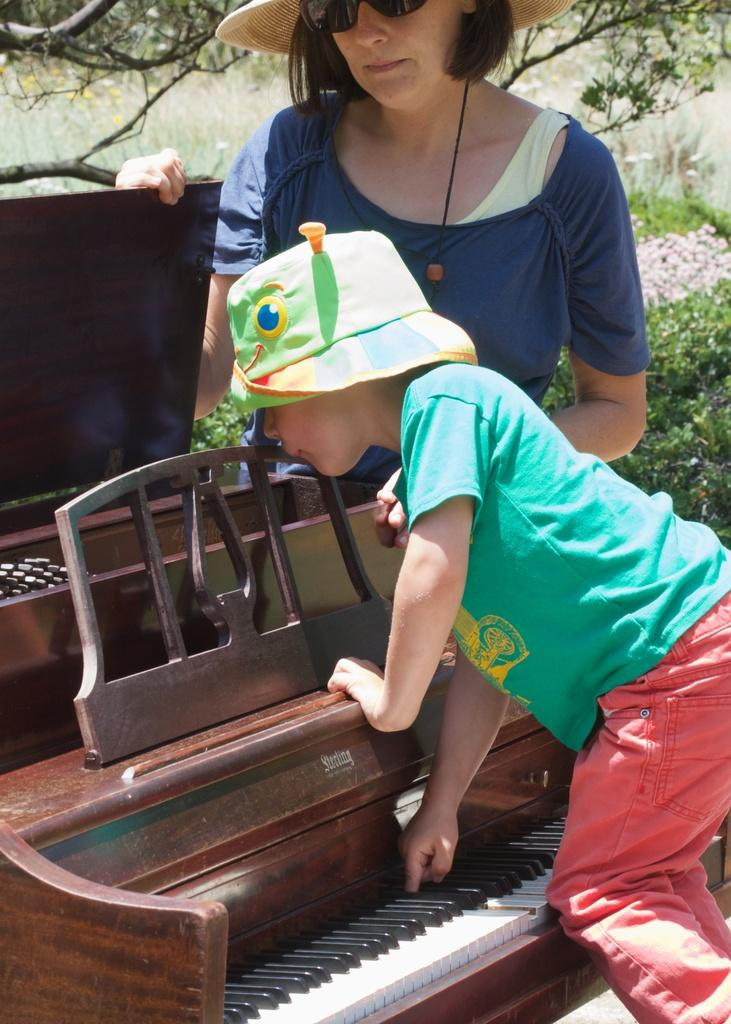What is the main subject of the picture? The main subject of the picture is a baby. What is the baby doing in the picture? The baby is playing piano in the picture. Who else is present in the image? There is a woman in the picture. What is the woman doing in the image? The woman is standing near the piano in the picture. What can be seen in the background of the image? There are trees near the baby and woman in the image. What type of apparel is the baby wearing while raking leaves in the image? There is no rake or leaves present in the image, and the baby is playing piano, not raking leaves. Additionally, there is no information about the baby's apparel in the provided facts. 